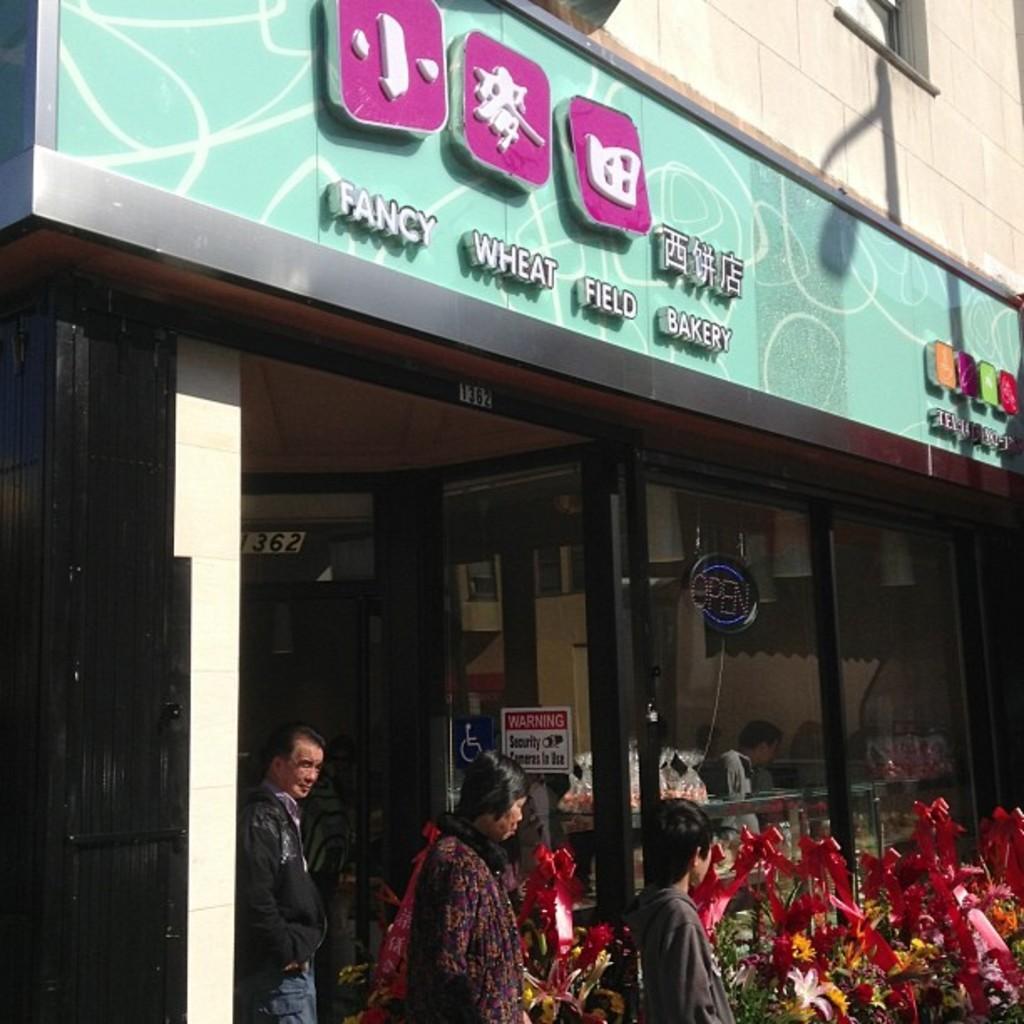Describe this image in one or two sentences. In this picture we can see a store, there are three persons at the bottom, at the right bottom we can see some flowers, we can see glasses of this store, there are two boards pasted on the glass, we can see a hoarding at the top of the picture, there is some text on the hoarding. 